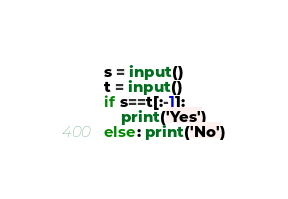Convert code to text. <code><loc_0><loc_0><loc_500><loc_500><_Python_>s = input()
t = input()
if s==t[:-1]:
    print('Yes')
else: print('No')</code> 